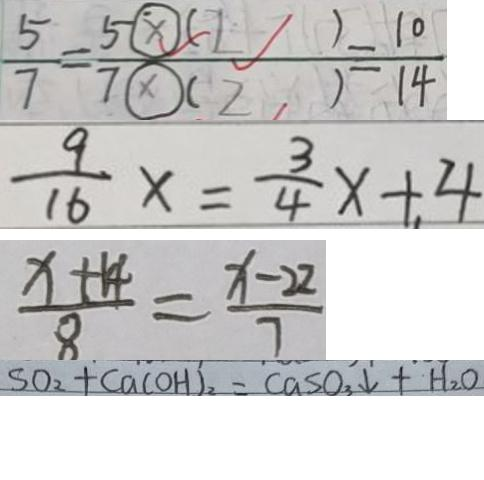Convert formula to latex. <formula><loc_0><loc_0><loc_500><loc_500>\frac { 5 } { 7 } = \frac { 5 \textcircled { \times } ( 2 ) } { 7 \textcircled { \times } ( 2 ) } = \frac { 1 0 } { 1 4 } 
 \frac { 9 } { 1 6 } x = \frac { 3 } { 4 } x + 4 
 \frac { x + 1 4 } { 8 } = \frac { x - 2 2 } { 7 } 
 S O _ { 2 } + C a ( O H ) _ { 2 } = C a S O _ { 3 } \downarrow + H _ { 2 } O</formula> 